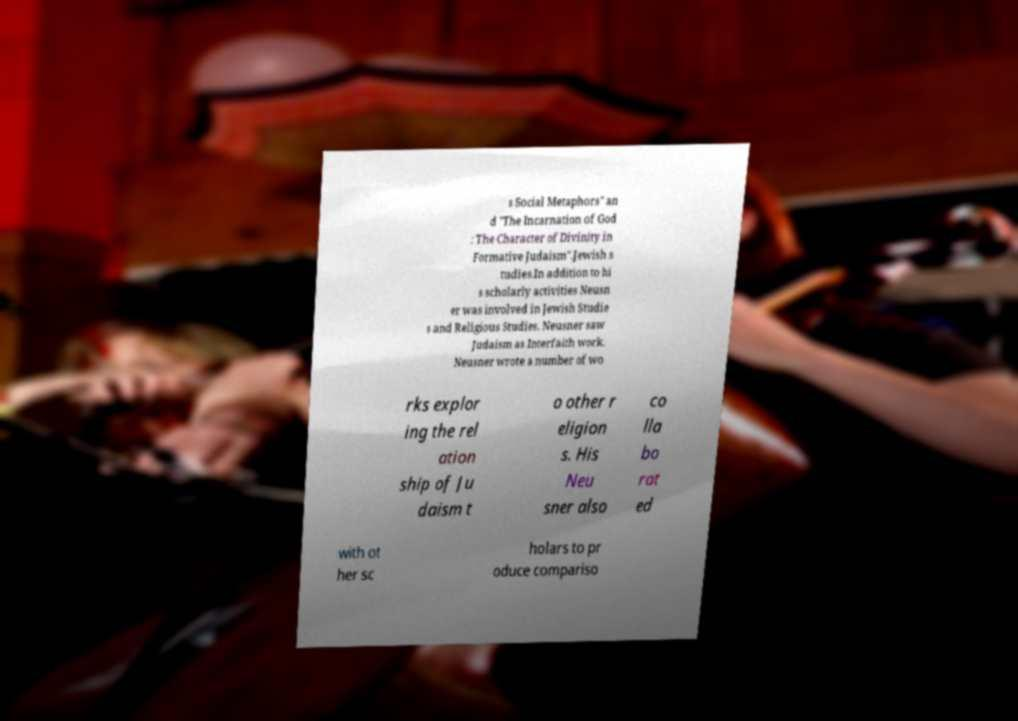Could you assist in decoding the text presented in this image and type it out clearly? s Social Metaphors" an d "The Incarnation of God : The Character of Divinity in Formative Judaism".Jewish s tudies.In addition to hi s scholarly activities Neusn er was involved in Jewish Studie s and Religious Studies. Neusner saw Judaism as Interfaith work. Neusner wrote a number of wo rks explor ing the rel ation ship of Ju daism t o other r eligion s. His Neu sner also co lla bo rat ed with ot her sc holars to pr oduce compariso 